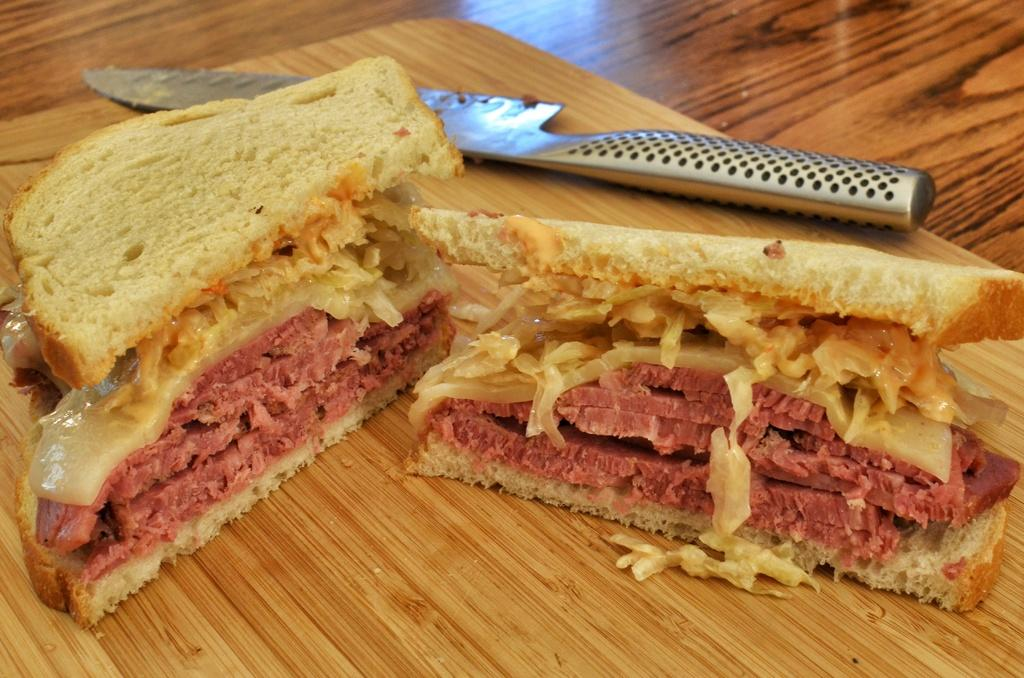What type of food can be seen in the image? There are two pieces of sandwich in the image. What utensil is present in the image? There is a knife in the image. Where is the knife placed? The knife is on a chop board. What surface is the chop board resting on? The chop board is on a table. How many legs can be seen on the sandwich in the image? There are no legs visible on the sandwich in the image, as sandwiches do not have legs. 